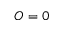Convert formula to latex. <formula><loc_0><loc_0><loc_500><loc_500>O = 0</formula> 